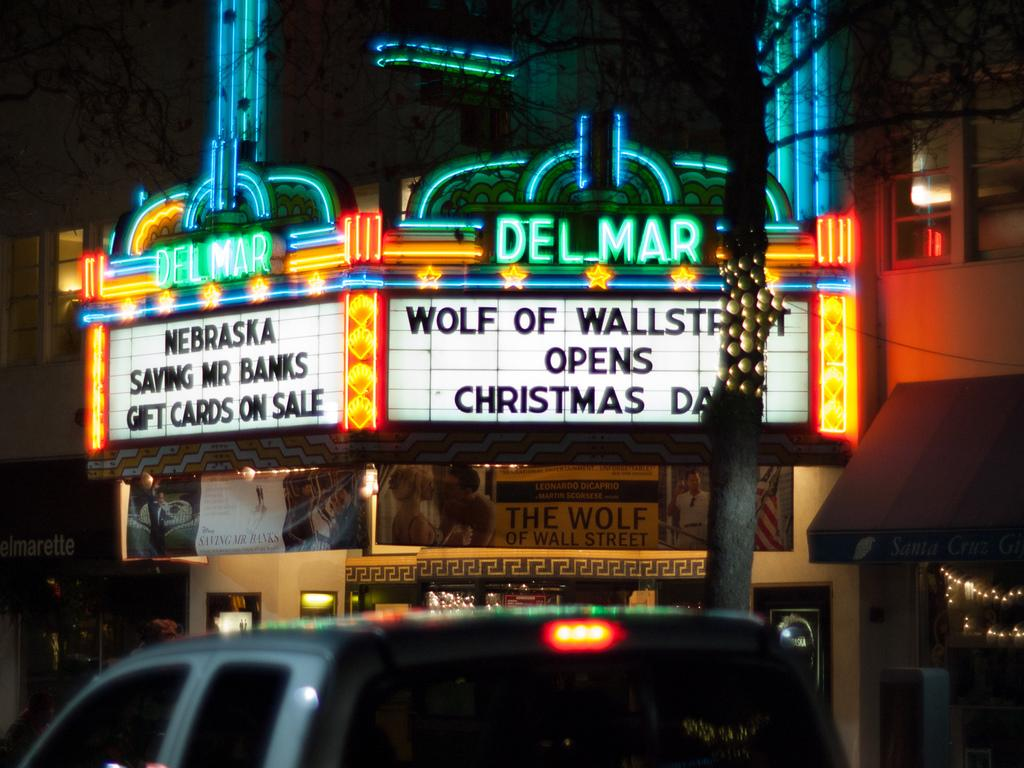<image>
Offer a succinct explanation of the picture presented. A theater marquee that says Wolf of Wall Street opens on Christmas day. 